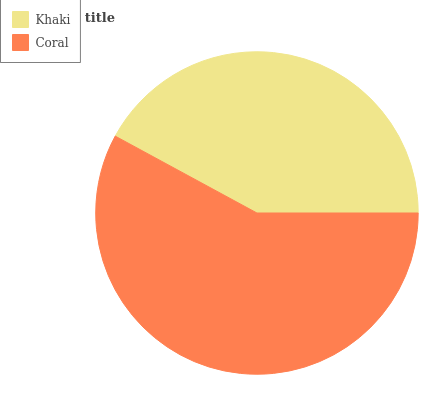Is Khaki the minimum?
Answer yes or no. Yes. Is Coral the maximum?
Answer yes or no. Yes. Is Coral the minimum?
Answer yes or no. No. Is Coral greater than Khaki?
Answer yes or no. Yes. Is Khaki less than Coral?
Answer yes or no. Yes. Is Khaki greater than Coral?
Answer yes or no. No. Is Coral less than Khaki?
Answer yes or no. No. Is Coral the high median?
Answer yes or no. Yes. Is Khaki the low median?
Answer yes or no. Yes. Is Khaki the high median?
Answer yes or no. No. Is Coral the low median?
Answer yes or no. No. 